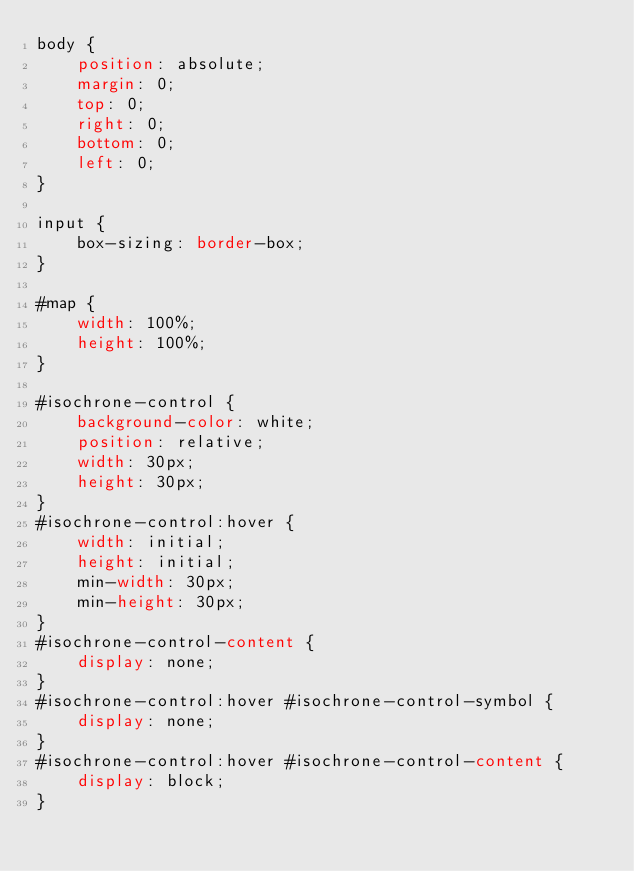Convert code to text. <code><loc_0><loc_0><loc_500><loc_500><_CSS_>body {
	position: absolute;
	margin: 0;
	top: 0;
	right: 0;
	bottom: 0;
	left: 0;
}

input {
	box-sizing: border-box;
}

#map {
	width: 100%;
	height: 100%;
}

#isochrone-control {
	background-color: white;
	position: relative;
	width: 30px;
	height: 30px;
}
#isochrone-control:hover {
	width: initial;
	height: initial;
	min-width: 30px;
	min-height: 30px;
}
#isochrone-control-content {
	display: none;
}
#isochrone-control:hover #isochrone-control-symbol {
	display: none;
}
#isochrone-control:hover #isochrone-control-content {
	display: block;
}
</code> 